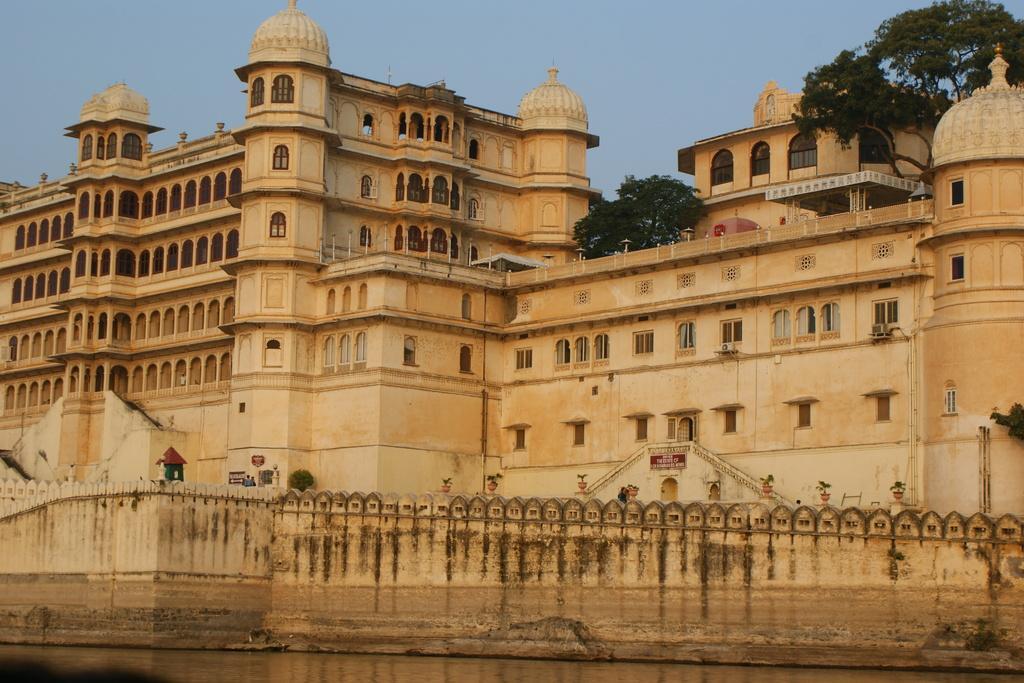Could you give a brief overview of what you see in this image? This is an outside view. At the bottom of the image I can see the water and there is a wall. In the middle of the image there is a building. At the top there are few trees. At the top of the image I can see the sky. 